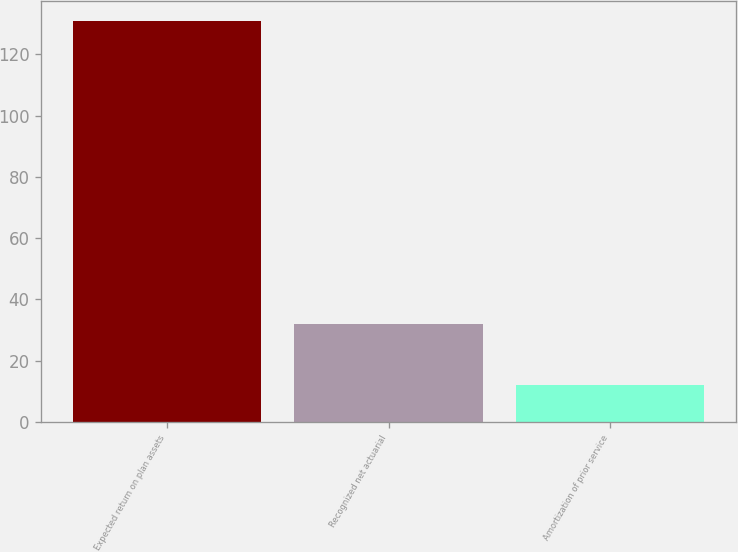<chart> <loc_0><loc_0><loc_500><loc_500><bar_chart><fcel>Expected return on plan assets<fcel>Recognized net actuarial<fcel>Amortization of prior service<nl><fcel>131<fcel>32<fcel>12<nl></chart> 